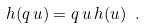<formula> <loc_0><loc_0><loc_500><loc_500>h ( q \, u ) = q \, u \, h ( u ) \ .</formula> 